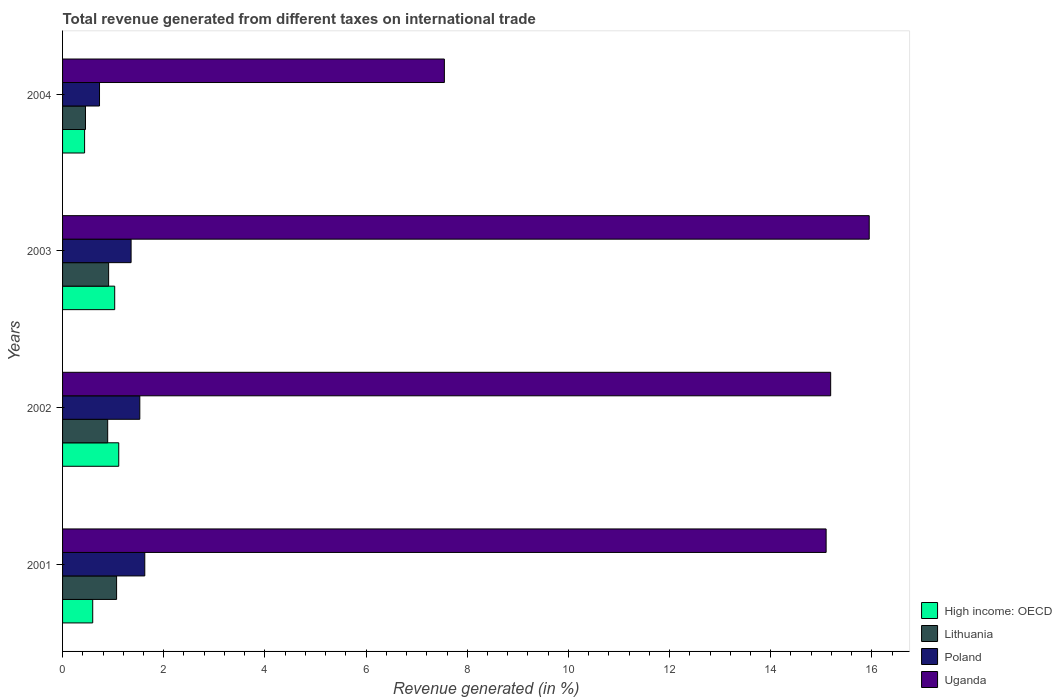How many groups of bars are there?
Offer a terse response. 4. Are the number of bars per tick equal to the number of legend labels?
Keep it short and to the point. Yes. Are the number of bars on each tick of the Y-axis equal?
Keep it short and to the point. Yes. How many bars are there on the 2nd tick from the bottom?
Ensure brevity in your answer.  4. What is the total revenue generated in Lithuania in 2003?
Provide a succinct answer. 0.91. Across all years, what is the maximum total revenue generated in Poland?
Your answer should be compact. 1.63. Across all years, what is the minimum total revenue generated in Poland?
Offer a very short reply. 0.73. In which year was the total revenue generated in Uganda maximum?
Offer a very short reply. 2003. What is the total total revenue generated in Uganda in the graph?
Give a very brief answer. 53.78. What is the difference between the total revenue generated in High income: OECD in 2001 and that in 2002?
Provide a short and direct response. -0.51. What is the difference between the total revenue generated in Poland in 2004 and the total revenue generated in Lithuania in 2003?
Provide a short and direct response. -0.18. What is the average total revenue generated in High income: OECD per year?
Ensure brevity in your answer.  0.79. In the year 2001, what is the difference between the total revenue generated in Poland and total revenue generated in High income: OECD?
Your response must be concise. 1.03. In how many years, is the total revenue generated in Uganda greater than 6.4 %?
Ensure brevity in your answer.  4. What is the ratio of the total revenue generated in High income: OECD in 2002 to that in 2004?
Make the answer very short. 2.55. What is the difference between the highest and the second highest total revenue generated in Lithuania?
Provide a short and direct response. 0.16. What is the difference between the highest and the lowest total revenue generated in Poland?
Ensure brevity in your answer.  0.89. What does the 3rd bar from the top in 2002 represents?
Your answer should be very brief. Lithuania. What does the 4th bar from the bottom in 2001 represents?
Offer a very short reply. Uganda. Is it the case that in every year, the sum of the total revenue generated in Uganda and total revenue generated in Lithuania is greater than the total revenue generated in Poland?
Provide a short and direct response. Yes. Are all the bars in the graph horizontal?
Keep it short and to the point. Yes. How many years are there in the graph?
Give a very brief answer. 4. Are the values on the major ticks of X-axis written in scientific E-notation?
Your response must be concise. No. Does the graph contain any zero values?
Give a very brief answer. No. What is the title of the graph?
Provide a short and direct response. Total revenue generated from different taxes on international trade. Does "Other small states" appear as one of the legend labels in the graph?
Provide a succinct answer. No. What is the label or title of the X-axis?
Keep it short and to the point. Revenue generated (in %). What is the Revenue generated (in %) of High income: OECD in 2001?
Keep it short and to the point. 0.6. What is the Revenue generated (in %) of Lithuania in 2001?
Make the answer very short. 1.07. What is the Revenue generated (in %) of Poland in 2001?
Make the answer very short. 1.63. What is the Revenue generated (in %) of Uganda in 2001?
Your response must be concise. 15.1. What is the Revenue generated (in %) of High income: OECD in 2002?
Offer a very short reply. 1.11. What is the Revenue generated (in %) of Lithuania in 2002?
Provide a succinct answer. 0.89. What is the Revenue generated (in %) in Poland in 2002?
Ensure brevity in your answer.  1.53. What is the Revenue generated (in %) of Uganda in 2002?
Your answer should be very brief. 15.19. What is the Revenue generated (in %) in High income: OECD in 2003?
Keep it short and to the point. 1.03. What is the Revenue generated (in %) of Lithuania in 2003?
Offer a very short reply. 0.91. What is the Revenue generated (in %) in Poland in 2003?
Your answer should be compact. 1.35. What is the Revenue generated (in %) in Uganda in 2003?
Your answer should be compact. 15.95. What is the Revenue generated (in %) in High income: OECD in 2004?
Your answer should be very brief. 0.44. What is the Revenue generated (in %) of Lithuania in 2004?
Provide a short and direct response. 0.45. What is the Revenue generated (in %) of Poland in 2004?
Offer a very short reply. 0.73. What is the Revenue generated (in %) in Uganda in 2004?
Make the answer very short. 7.55. Across all years, what is the maximum Revenue generated (in %) of High income: OECD?
Give a very brief answer. 1.11. Across all years, what is the maximum Revenue generated (in %) in Lithuania?
Ensure brevity in your answer.  1.07. Across all years, what is the maximum Revenue generated (in %) of Poland?
Keep it short and to the point. 1.63. Across all years, what is the maximum Revenue generated (in %) in Uganda?
Make the answer very short. 15.95. Across all years, what is the minimum Revenue generated (in %) in High income: OECD?
Your response must be concise. 0.44. Across all years, what is the minimum Revenue generated (in %) in Lithuania?
Keep it short and to the point. 0.45. Across all years, what is the minimum Revenue generated (in %) of Poland?
Ensure brevity in your answer.  0.73. Across all years, what is the minimum Revenue generated (in %) in Uganda?
Your answer should be very brief. 7.55. What is the total Revenue generated (in %) in High income: OECD in the graph?
Offer a terse response. 3.17. What is the total Revenue generated (in %) in Lithuania in the graph?
Your response must be concise. 3.32. What is the total Revenue generated (in %) in Poland in the graph?
Provide a short and direct response. 5.24. What is the total Revenue generated (in %) of Uganda in the graph?
Provide a succinct answer. 53.78. What is the difference between the Revenue generated (in %) of High income: OECD in 2001 and that in 2002?
Your answer should be compact. -0.51. What is the difference between the Revenue generated (in %) in Lithuania in 2001 and that in 2002?
Make the answer very short. 0.18. What is the difference between the Revenue generated (in %) of Poland in 2001 and that in 2002?
Your response must be concise. 0.1. What is the difference between the Revenue generated (in %) in Uganda in 2001 and that in 2002?
Your answer should be very brief. -0.09. What is the difference between the Revenue generated (in %) of High income: OECD in 2001 and that in 2003?
Give a very brief answer. -0.43. What is the difference between the Revenue generated (in %) in Lithuania in 2001 and that in 2003?
Your answer should be very brief. 0.16. What is the difference between the Revenue generated (in %) of Poland in 2001 and that in 2003?
Offer a terse response. 0.27. What is the difference between the Revenue generated (in %) of Uganda in 2001 and that in 2003?
Give a very brief answer. -0.85. What is the difference between the Revenue generated (in %) in High income: OECD in 2001 and that in 2004?
Provide a short and direct response. 0.16. What is the difference between the Revenue generated (in %) of Lithuania in 2001 and that in 2004?
Your answer should be compact. 0.61. What is the difference between the Revenue generated (in %) of Poland in 2001 and that in 2004?
Your response must be concise. 0.89. What is the difference between the Revenue generated (in %) of Uganda in 2001 and that in 2004?
Keep it short and to the point. 7.55. What is the difference between the Revenue generated (in %) of High income: OECD in 2002 and that in 2003?
Offer a terse response. 0.08. What is the difference between the Revenue generated (in %) of Lithuania in 2002 and that in 2003?
Your answer should be very brief. -0.02. What is the difference between the Revenue generated (in %) of Poland in 2002 and that in 2003?
Ensure brevity in your answer.  0.17. What is the difference between the Revenue generated (in %) in Uganda in 2002 and that in 2003?
Give a very brief answer. -0.76. What is the difference between the Revenue generated (in %) in High income: OECD in 2002 and that in 2004?
Give a very brief answer. 0.68. What is the difference between the Revenue generated (in %) in Lithuania in 2002 and that in 2004?
Offer a terse response. 0.44. What is the difference between the Revenue generated (in %) of Poland in 2002 and that in 2004?
Offer a very short reply. 0.8. What is the difference between the Revenue generated (in %) in Uganda in 2002 and that in 2004?
Ensure brevity in your answer.  7.64. What is the difference between the Revenue generated (in %) in High income: OECD in 2003 and that in 2004?
Your answer should be very brief. 0.6. What is the difference between the Revenue generated (in %) in Lithuania in 2003 and that in 2004?
Provide a succinct answer. 0.46. What is the difference between the Revenue generated (in %) of Poland in 2003 and that in 2004?
Give a very brief answer. 0.62. What is the difference between the Revenue generated (in %) of Uganda in 2003 and that in 2004?
Give a very brief answer. 8.4. What is the difference between the Revenue generated (in %) in High income: OECD in 2001 and the Revenue generated (in %) in Lithuania in 2002?
Provide a short and direct response. -0.3. What is the difference between the Revenue generated (in %) of High income: OECD in 2001 and the Revenue generated (in %) of Poland in 2002?
Provide a succinct answer. -0.93. What is the difference between the Revenue generated (in %) in High income: OECD in 2001 and the Revenue generated (in %) in Uganda in 2002?
Provide a short and direct response. -14.59. What is the difference between the Revenue generated (in %) in Lithuania in 2001 and the Revenue generated (in %) in Poland in 2002?
Your answer should be very brief. -0.46. What is the difference between the Revenue generated (in %) in Lithuania in 2001 and the Revenue generated (in %) in Uganda in 2002?
Provide a short and direct response. -14.12. What is the difference between the Revenue generated (in %) of Poland in 2001 and the Revenue generated (in %) of Uganda in 2002?
Ensure brevity in your answer.  -13.56. What is the difference between the Revenue generated (in %) in High income: OECD in 2001 and the Revenue generated (in %) in Lithuania in 2003?
Provide a short and direct response. -0.31. What is the difference between the Revenue generated (in %) of High income: OECD in 2001 and the Revenue generated (in %) of Poland in 2003?
Keep it short and to the point. -0.76. What is the difference between the Revenue generated (in %) of High income: OECD in 2001 and the Revenue generated (in %) of Uganda in 2003?
Your answer should be very brief. -15.35. What is the difference between the Revenue generated (in %) of Lithuania in 2001 and the Revenue generated (in %) of Poland in 2003?
Your answer should be compact. -0.29. What is the difference between the Revenue generated (in %) of Lithuania in 2001 and the Revenue generated (in %) of Uganda in 2003?
Provide a succinct answer. -14.88. What is the difference between the Revenue generated (in %) in Poland in 2001 and the Revenue generated (in %) in Uganda in 2003?
Offer a very short reply. -14.32. What is the difference between the Revenue generated (in %) of High income: OECD in 2001 and the Revenue generated (in %) of Lithuania in 2004?
Your answer should be compact. 0.14. What is the difference between the Revenue generated (in %) in High income: OECD in 2001 and the Revenue generated (in %) in Poland in 2004?
Make the answer very short. -0.13. What is the difference between the Revenue generated (in %) of High income: OECD in 2001 and the Revenue generated (in %) of Uganda in 2004?
Ensure brevity in your answer.  -6.95. What is the difference between the Revenue generated (in %) in Lithuania in 2001 and the Revenue generated (in %) in Poland in 2004?
Ensure brevity in your answer.  0.34. What is the difference between the Revenue generated (in %) in Lithuania in 2001 and the Revenue generated (in %) in Uganda in 2004?
Your response must be concise. -6.48. What is the difference between the Revenue generated (in %) of Poland in 2001 and the Revenue generated (in %) of Uganda in 2004?
Your response must be concise. -5.92. What is the difference between the Revenue generated (in %) of High income: OECD in 2002 and the Revenue generated (in %) of Lithuania in 2003?
Ensure brevity in your answer.  0.2. What is the difference between the Revenue generated (in %) in High income: OECD in 2002 and the Revenue generated (in %) in Poland in 2003?
Your answer should be compact. -0.24. What is the difference between the Revenue generated (in %) in High income: OECD in 2002 and the Revenue generated (in %) in Uganda in 2003?
Offer a terse response. -14.84. What is the difference between the Revenue generated (in %) of Lithuania in 2002 and the Revenue generated (in %) of Poland in 2003?
Your response must be concise. -0.46. What is the difference between the Revenue generated (in %) in Lithuania in 2002 and the Revenue generated (in %) in Uganda in 2003?
Provide a short and direct response. -15.05. What is the difference between the Revenue generated (in %) in Poland in 2002 and the Revenue generated (in %) in Uganda in 2003?
Offer a very short reply. -14.42. What is the difference between the Revenue generated (in %) of High income: OECD in 2002 and the Revenue generated (in %) of Lithuania in 2004?
Make the answer very short. 0.66. What is the difference between the Revenue generated (in %) of High income: OECD in 2002 and the Revenue generated (in %) of Poland in 2004?
Provide a short and direct response. 0.38. What is the difference between the Revenue generated (in %) of High income: OECD in 2002 and the Revenue generated (in %) of Uganda in 2004?
Provide a short and direct response. -6.44. What is the difference between the Revenue generated (in %) in Lithuania in 2002 and the Revenue generated (in %) in Poland in 2004?
Give a very brief answer. 0.16. What is the difference between the Revenue generated (in %) of Lithuania in 2002 and the Revenue generated (in %) of Uganda in 2004?
Your response must be concise. -6.66. What is the difference between the Revenue generated (in %) in Poland in 2002 and the Revenue generated (in %) in Uganda in 2004?
Provide a short and direct response. -6.02. What is the difference between the Revenue generated (in %) of High income: OECD in 2003 and the Revenue generated (in %) of Lithuania in 2004?
Your answer should be compact. 0.58. What is the difference between the Revenue generated (in %) of High income: OECD in 2003 and the Revenue generated (in %) of Uganda in 2004?
Provide a short and direct response. -6.52. What is the difference between the Revenue generated (in %) in Lithuania in 2003 and the Revenue generated (in %) in Poland in 2004?
Keep it short and to the point. 0.18. What is the difference between the Revenue generated (in %) in Lithuania in 2003 and the Revenue generated (in %) in Uganda in 2004?
Ensure brevity in your answer.  -6.64. What is the difference between the Revenue generated (in %) of Poland in 2003 and the Revenue generated (in %) of Uganda in 2004?
Your answer should be very brief. -6.19. What is the average Revenue generated (in %) of High income: OECD per year?
Offer a very short reply. 0.79. What is the average Revenue generated (in %) in Lithuania per year?
Offer a very short reply. 0.83. What is the average Revenue generated (in %) of Poland per year?
Give a very brief answer. 1.31. What is the average Revenue generated (in %) in Uganda per year?
Provide a short and direct response. 13.44. In the year 2001, what is the difference between the Revenue generated (in %) in High income: OECD and Revenue generated (in %) in Lithuania?
Your response must be concise. -0.47. In the year 2001, what is the difference between the Revenue generated (in %) of High income: OECD and Revenue generated (in %) of Poland?
Offer a very short reply. -1.03. In the year 2001, what is the difference between the Revenue generated (in %) in High income: OECD and Revenue generated (in %) in Uganda?
Offer a very short reply. -14.5. In the year 2001, what is the difference between the Revenue generated (in %) in Lithuania and Revenue generated (in %) in Poland?
Your answer should be very brief. -0.56. In the year 2001, what is the difference between the Revenue generated (in %) of Lithuania and Revenue generated (in %) of Uganda?
Provide a short and direct response. -14.03. In the year 2001, what is the difference between the Revenue generated (in %) of Poland and Revenue generated (in %) of Uganda?
Make the answer very short. -13.47. In the year 2002, what is the difference between the Revenue generated (in %) of High income: OECD and Revenue generated (in %) of Lithuania?
Provide a short and direct response. 0.22. In the year 2002, what is the difference between the Revenue generated (in %) in High income: OECD and Revenue generated (in %) in Poland?
Your response must be concise. -0.42. In the year 2002, what is the difference between the Revenue generated (in %) of High income: OECD and Revenue generated (in %) of Uganda?
Your response must be concise. -14.07. In the year 2002, what is the difference between the Revenue generated (in %) in Lithuania and Revenue generated (in %) in Poland?
Keep it short and to the point. -0.64. In the year 2002, what is the difference between the Revenue generated (in %) in Lithuania and Revenue generated (in %) in Uganda?
Your response must be concise. -14.29. In the year 2002, what is the difference between the Revenue generated (in %) of Poland and Revenue generated (in %) of Uganda?
Your answer should be very brief. -13.66. In the year 2003, what is the difference between the Revenue generated (in %) of High income: OECD and Revenue generated (in %) of Lithuania?
Make the answer very short. 0.12. In the year 2003, what is the difference between the Revenue generated (in %) in High income: OECD and Revenue generated (in %) in Poland?
Your answer should be compact. -0.32. In the year 2003, what is the difference between the Revenue generated (in %) of High income: OECD and Revenue generated (in %) of Uganda?
Give a very brief answer. -14.92. In the year 2003, what is the difference between the Revenue generated (in %) of Lithuania and Revenue generated (in %) of Poland?
Ensure brevity in your answer.  -0.44. In the year 2003, what is the difference between the Revenue generated (in %) in Lithuania and Revenue generated (in %) in Uganda?
Keep it short and to the point. -15.04. In the year 2003, what is the difference between the Revenue generated (in %) of Poland and Revenue generated (in %) of Uganda?
Give a very brief answer. -14.59. In the year 2004, what is the difference between the Revenue generated (in %) of High income: OECD and Revenue generated (in %) of Lithuania?
Give a very brief answer. -0.02. In the year 2004, what is the difference between the Revenue generated (in %) of High income: OECD and Revenue generated (in %) of Poland?
Your response must be concise. -0.3. In the year 2004, what is the difference between the Revenue generated (in %) of High income: OECD and Revenue generated (in %) of Uganda?
Make the answer very short. -7.11. In the year 2004, what is the difference between the Revenue generated (in %) of Lithuania and Revenue generated (in %) of Poland?
Provide a succinct answer. -0.28. In the year 2004, what is the difference between the Revenue generated (in %) of Lithuania and Revenue generated (in %) of Uganda?
Offer a terse response. -7.1. In the year 2004, what is the difference between the Revenue generated (in %) in Poland and Revenue generated (in %) in Uganda?
Your answer should be compact. -6.82. What is the ratio of the Revenue generated (in %) in High income: OECD in 2001 to that in 2002?
Keep it short and to the point. 0.54. What is the ratio of the Revenue generated (in %) in Lithuania in 2001 to that in 2002?
Keep it short and to the point. 1.2. What is the ratio of the Revenue generated (in %) of Poland in 2001 to that in 2002?
Ensure brevity in your answer.  1.06. What is the ratio of the Revenue generated (in %) in High income: OECD in 2001 to that in 2003?
Your answer should be very brief. 0.58. What is the ratio of the Revenue generated (in %) of Lithuania in 2001 to that in 2003?
Provide a succinct answer. 1.17. What is the ratio of the Revenue generated (in %) in Poland in 2001 to that in 2003?
Offer a terse response. 1.2. What is the ratio of the Revenue generated (in %) of Uganda in 2001 to that in 2003?
Your response must be concise. 0.95. What is the ratio of the Revenue generated (in %) of High income: OECD in 2001 to that in 2004?
Provide a short and direct response. 1.37. What is the ratio of the Revenue generated (in %) of Lithuania in 2001 to that in 2004?
Your answer should be compact. 2.36. What is the ratio of the Revenue generated (in %) of Poland in 2001 to that in 2004?
Your answer should be very brief. 2.22. What is the ratio of the Revenue generated (in %) of Uganda in 2001 to that in 2004?
Make the answer very short. 2. What is the ratio of the Revenue generated (in %) in High income: OECD in 2002 to that in 2003?
Ensure brevity in your answer.  1.08. What is the ratio of the Revenue generated (in %) of Lithuania in 2002 to that in 2003?
Offer a very short reply. 0.98. What is the ratio of the Revenue generated (in %) of Poland in 2002 to that in 2003?
Keep it short and to the point. 1.13. What is the ratio of the Revenue generated (in %) of Uganda in 2002 to that in 2003?
Your answer should be very brief. 0.95. What is the ratio of the Revenue generated (in %) in High income: OECD in 2002 to that in 2004?
Ensure brevity in your answer.  2.55. What is the ratio of the Revenue generated (in %) of Lithuania in 2002 to that in 2004?
Keep it short and to the point. 1.97. What is the ratio of the Revenue generated (in %) in Poland in 2002 to that in 2004?
Make the answer very short. 2.09. What is the ratio of the Revenue generated (in %) in Uganda in 2002 to that in 2004?
Offer a terse response. 2.01. What is the ratio of the Revenue generated (in %) in High income: OECD in 2003 to that in 2004?
Your answer should be very brief. 2.37. What is the ratio of the Revenue generated (in %) of Lithuania in 2003 to that in 2004?
Offer a terse response. 2.01. What is the ratio of the Revenue generated (in %) in Poland in 2003 to that in 2004?
Provide a succinct answer. 1.85. What is the ratio of the Revenue generated (in %) of Uganda in 2003 to that in 2004?
Keep it short and to the point. 2.11. What is the difference between the highest and the second highest Revenue generated (in %) of High income: OECD?
Your answer should be compact. 0.08. What is the difference between the highest and the second highest Revenue generated (in %) of Lithuania?
Your answer should be very brief. 0.16. What is the difference between the highest and the second highest Revenue generated (in %) in Poland?
Offer a very short reply. 0.1. What is the difference between the highest and the second highest Revenue generated (in %) in Uganda?
Your response must be concise. 0.76. What is the difference between the highest and the lowest Revenue generated (in %) of High income: OECD?
Keep it short and to the point. 0.68. What is the difference between the highest and the lowest Revenue generated (in %) of Lithuania?
Offer a terse response. 0.61. What is the difference between the highest and the lowest Revenue generated (in %) in Poland?
Your response must be concise. 0.89. What is the difference between the highest and the lowest Revenue generated (in %) in Uganda?
Ensure brevity in your answer.  8.4. 